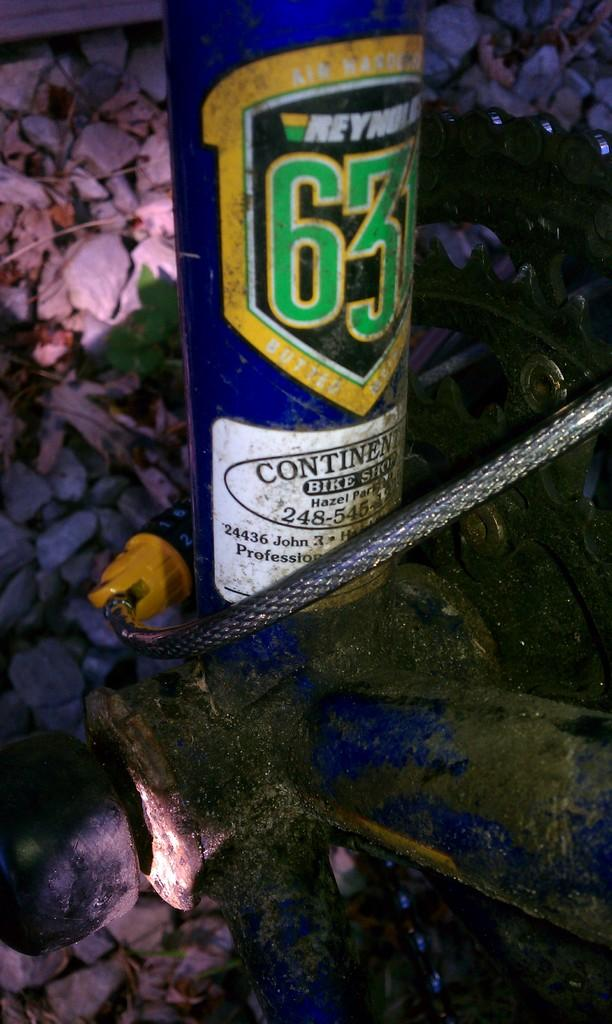<image>
Give a short and clear explanation of the subsequent image. A bicycle cord and other parts are next to a can that says "Reynolds 631". 